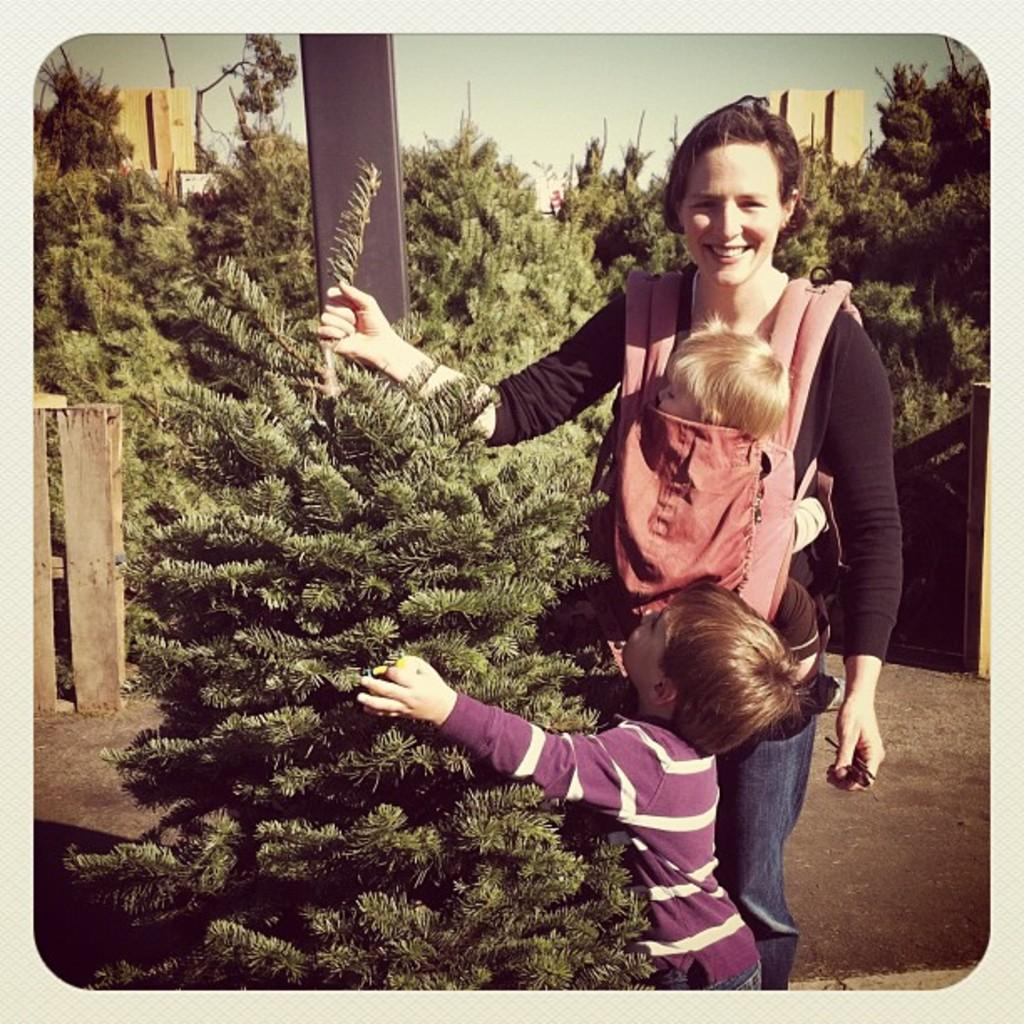Who is present in the image? There is a woman and two kids in the image. What are the woman and kids doing in the image? The woman and kids are standing at a tree. What can be seen in the background of the image? There is a pole, trees, buildings, and the sky visible in the background of the image. What fact about the giants can be observed in the image? There are no giants present in the image, so no such fact can be observed. 